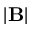Convert formula to latex. <formula><loc_0><loc_0><loc_500><loc_500>| B |</formula> 